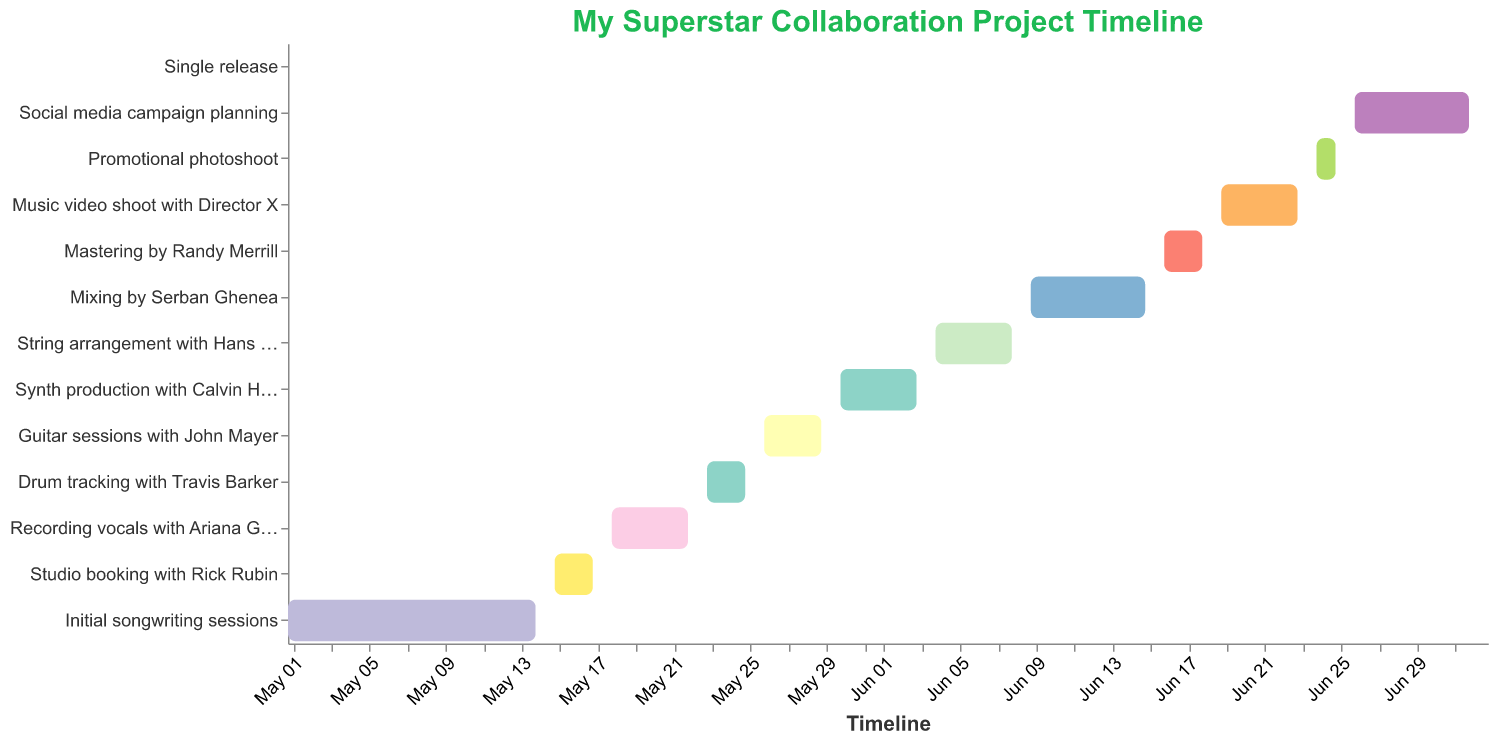Which task starts the earliest on the timeline? The task that starts the earliest will have the earliest start date on the timeline. Referring to the Gantt chart, the "Initial songwriting sessions" begin on May 1, 2023, which is earlier than any other task.
Answer: Initial songwriting sessions Which task lasts the longest? To determine the task which lasts the longest, compare the duration (End Date - Start Date) of each task. The "Social media campaign planning" task starts on June 26 and ends on July 2, lasting 7 days, which is the longest duration among all tasks.
Answer: Social media campaign planning What is the total duration of "Recording vocals with Ariana Grande"? Calculate the duration by subtracting the start date from the end date: May 18 to May 22. This results in a duration of 5 days (including both the start and end dates).
Answer: 5 days Which task follows "Recording vocals with Ariana Grande"? Referring to the timeline, the task that directly follows "Recording vocals with Ariana Grande" (ending on May 22) is "Drum tracking with Travis Barker," which starts on May 23.
Answer: Drum tracking with Travis Barker How many days are allotted for "Mastering by Randy Merrill"? Find the duration by subtracting the start date from the end date: June 16 to June 18 results in a duration of 3 days (counting both the start and end dates).
Answer: 3 days Which task starts immediately after "String arrangement with Hans Zimmer"? Looking at the Gantt chart, the task that starts immediately after June 8 (end date for "String arrangement with Hans Zimmer") is "Mixing by Serban Ghenea," which starts on June 9.
Answer: Mixing by Serban Ghenea Which task overlaps with "Studio booking with Rick Rubin"? To find overlapping tasks, compare the date ranges. "Recording vocals with Ariana Grande" starts on May 18 and "Studio booking with Rick Rubin" ends on May 17, indicating no overlap. No other tasks overlap with these dates.
Answer: None How many tasks are scheduled before "Drum tracking with Travis Barker"? The tasks before "Drum tracking with Travis Barker" (starting on May 23) are: "Initial songwriting sessions," "Studio booking with Rick Rubin," and "Recording vocals with Ariana Grande." There are three tasks in total.
Answer: 3 tasks Which two tasks have the shortest duration? To find the shortest durations, compare the lengths of all tasks: "Studio booking with Rick Rubin" and "Promotional photoshoot" both last 3 days, which are the shortest durations.
Answer: Studio booking with Rick Rubin, Promotional photoshoot Which tasks involve featured artists or producers? Tasks including collaboration with specific artists or producers are highlighted in their titles: "Studio booking with Rick Rubin," "Recording vocals with Ariana Grande," "Drum tracking with Travis Barker," "Guitar sessions with John Mayer," "Synth production with Calvin Harris," "String arrangement with Hans Zimmer," and "Mixing by Serban Ghenea."
Answer: 7 tasks: Studio booking with Rick Rubin, Recording vocals with Ariana Grande, Drum tracking with Travis Barker, Guitar sessions with John Mayer, Synth production with Calvin Harris, String arrangement with Hans Zimmer, Mixing by Serban Ghenea 